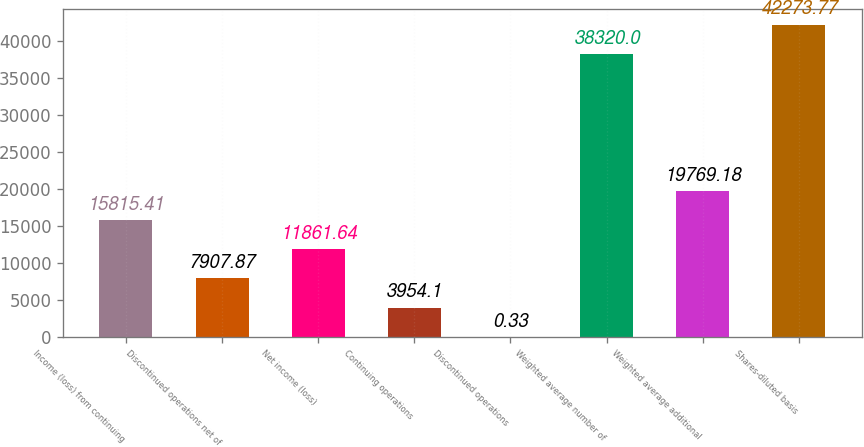<chart> <loc_0><loc_0><loc_500><loc_500><bar_chart><fcel>Income (loss) from continuing<fcel>Discontinued operations net of<fcel>Net income (loss)<fcel>Continuing operations<fcel>Discontinued operations<fcel>Weighted average number of<fcel>Weighted average additional<fcel>Shares-diluted basis<nl><fcel>15815.4<fcel>7907.87<fcel>11861.6<fcel>3954.1<fcel>0.33<fcel>38320<fcel>19769.2<fcel>42273.8<nl></chart> 